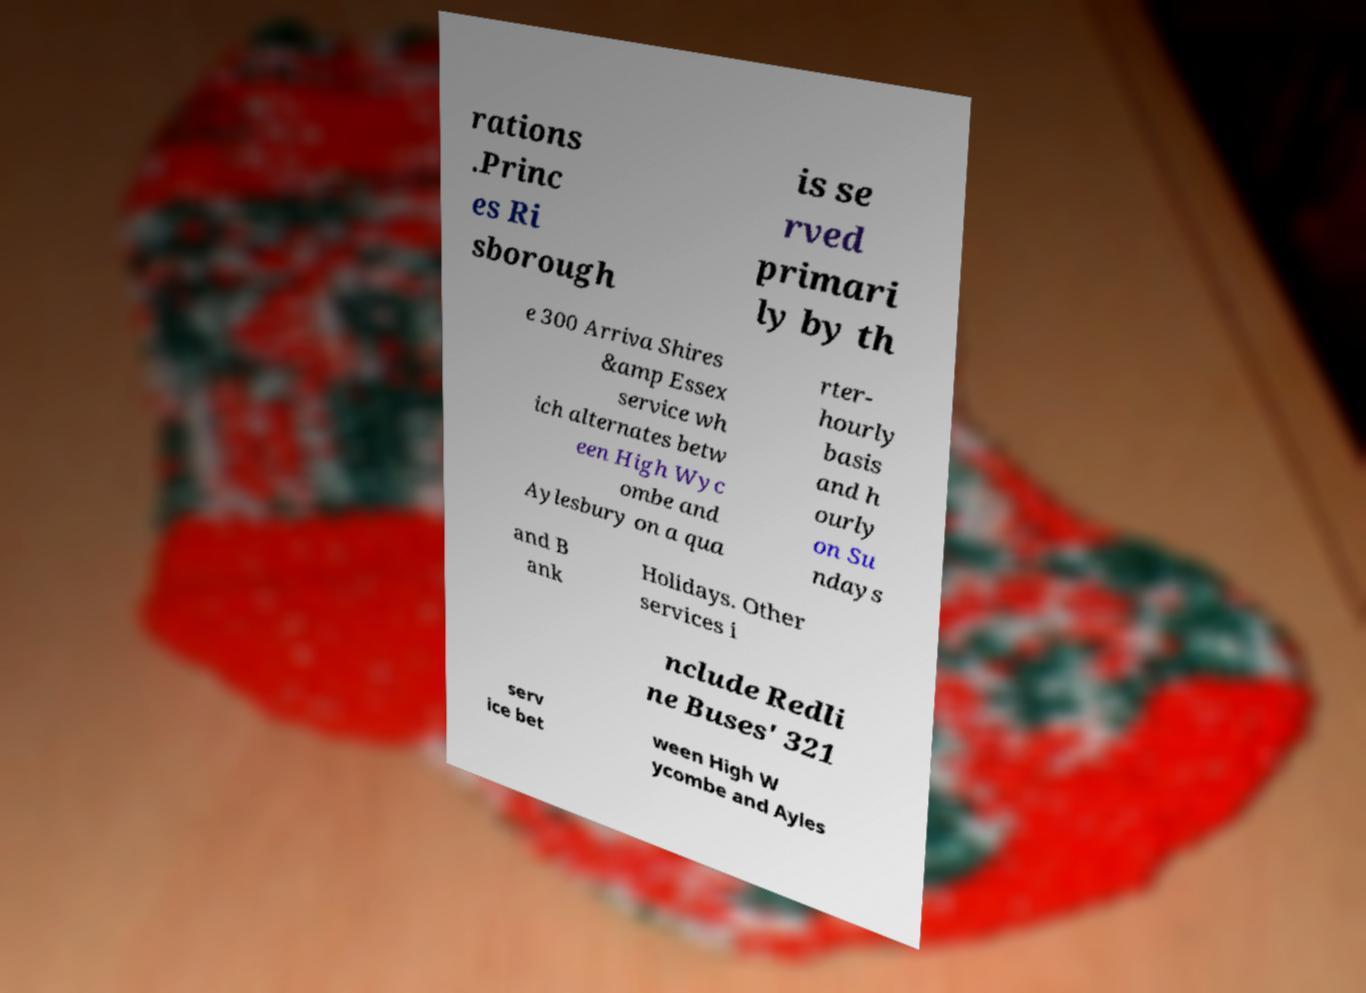What messages or text are displayed in this image? I need them in a readable, typed format. rations .Princ es Ri sborough is se rved primari ly by th e 300 Arriva Shires &amp Essex service wh ich alternates betw een High Wyc ombe and Aylesbury on a qua rter- hourly basis and h ourly on Su ndays and B ank Holidays. Other services i nclude Redli ne Buses' 321 serv ice bet ween High W ycombe and Ayles 